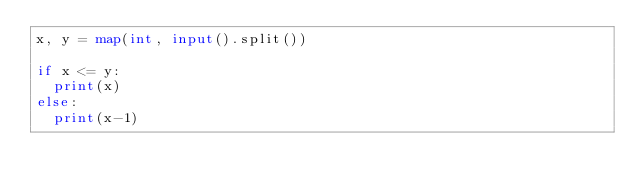Convert code to text. <code><loc_0><loc_0><loc_500><loc_500><_Python_>x, y = map(int, input().split())

if x <= y:
  print(x)
else:
  print(x-1)</code> 